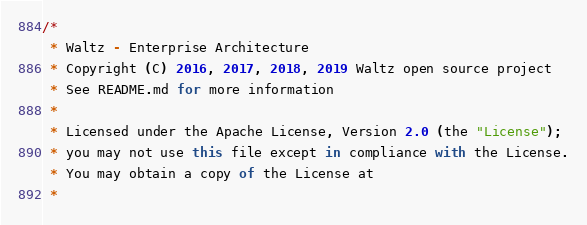<code> <loc_0><loc_0><loc_500><loc_500><_JavaScript_>/*
 * Waltz - Enterprise Architecture
 * Copyright (C) 2016, 2017, 2018, 2019 Waltz open source project
 * See README.md for more information
 *
 * Licensed under the Apache License, Version 2.0 (the "License");
 * you may not use this file except in compliance with the License.
 * You may obtain a copy of the License at
 *</code> 